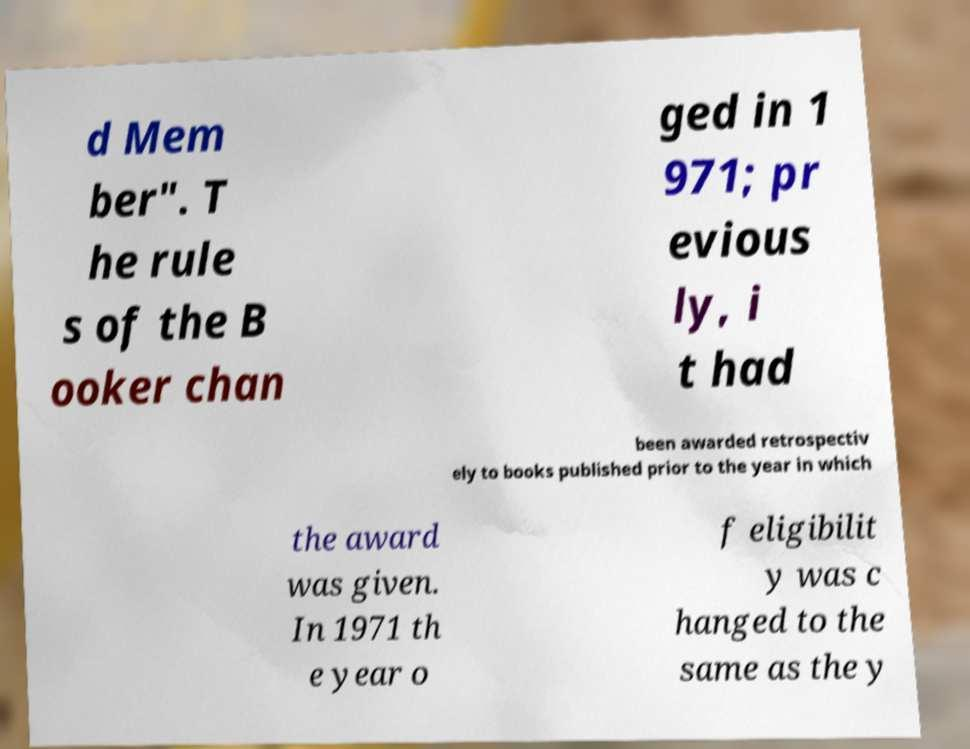Could you assist in decoding the text presented in this image and type it out clearly? d Mem ber". T he rule s of the B ooker chan ged in 1 971; pr evious ly, i t had been awarded retrospectiv ely to books published prior to the year in which the award was given. In 1971 th e year o f eligibilit y was c hanged to the same as the y 